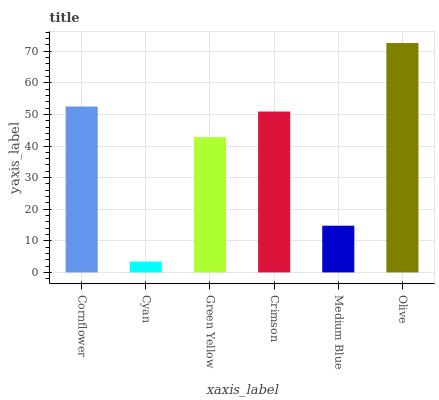Is Green Yellow the minimum?
Answer yes or no. No. Is Green Yellow the maximum?
Answer yes or no. No. Is Green Yellow greater than Cyan?
Answer yes or no. Yes. Is Cyan less than Green Yellow?
Answer yes or no. Yes. Is Cyan greater than Green Yellow?
Answer yes or no. No. Is Green Yellow less than Cyan?
Answer yes or no. No. Is Crimson the high median?
Answer yes or no. Yes. Is Green Yellow the low median?
Answer yes or no. Yes. Is Medium Blue the high median?
Answer yes or no. No. Is Cyan the low median?
Answer yes or no. No. 